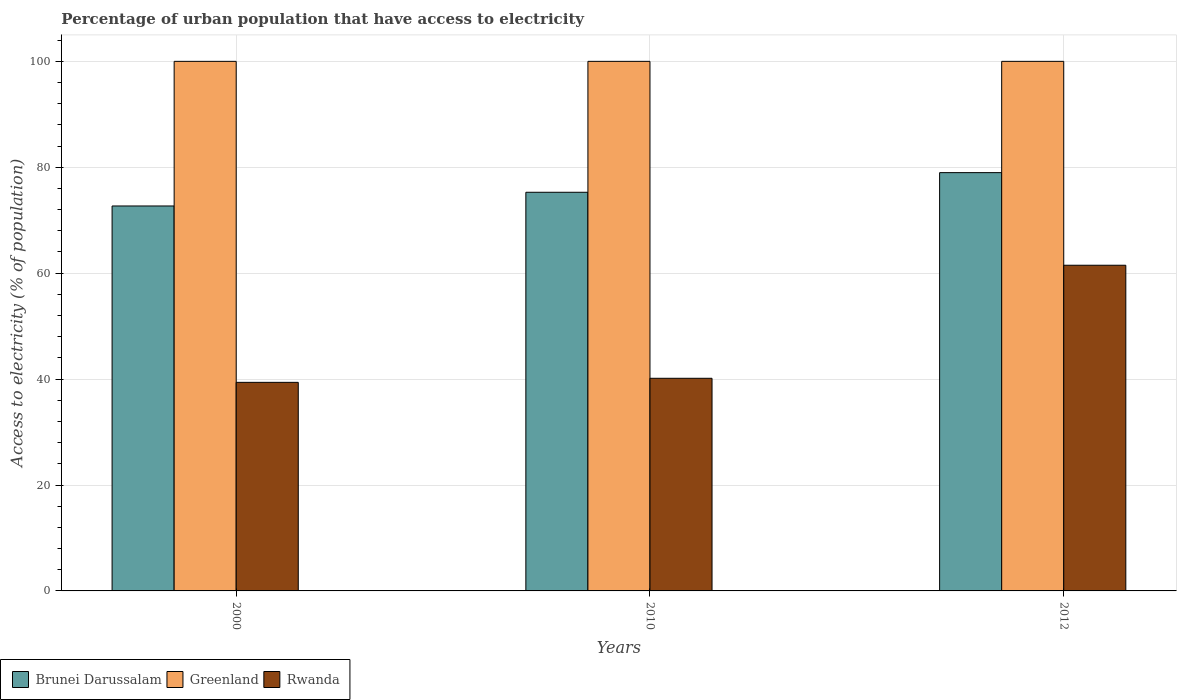How many groups of bars are there?
Ensure brevity in your answer.  3. Are the number of bars per tick equal to the number of legend labels?
Make the answer very short. Yes. Are the number of bars on each tick of the X-axis equal?
Keep it short and to the point. Yes. In how many cases, is the number of bars for a given year not equal to the number of legend labels?
Provide a succinct answer. 0. What is the percentage of urban population that have access to electricity in Brunei Darussalam in 2000?
Offer a very short reply. 72.69. Across all years, what is the maximum percentage of urban population that have access to electricity in Rwanda?
Keep it short and to the point. 61.5. Across all years, what is the minimum percentage of urban population that have access to electricity in Greenland?
Provide a short and direct response. 100. In which year was the percentage of urban population that have access to electricity in Rwanda minimum?
Provide a short and direct response. 2000. What is the total percentage of urban population that have access to electricity in Brunei Darussalam in the graph?
Your response must be concise. 226.96. What is the difference between the percentage of urban population that have access to electricity in Rwanda in 2010 and that in 2012?
Provide a succinct answer. -21.35. What is the difference between the percentage of urban population that have access to electricity in Brunei Darussalam in 2000 and the percentage of urban population that have access to electricity in Rwanda in 2012?
Provide a short and direct response. 11.19. What is the average percentage of urban population that have access to electricity in Greenland per year?
Make the answer very short. 100. In the year 2012, what is the difference between the percentage of urban population that have access to electricity in Rwanda and percentage of urban population that have access to electricity in Greenland?
Your response must be concise. -38.5. In how many years, is the percentage of urban population that have access to electricity in Brunei Darussalam greater than 4 %?
Offer a terse response. 3. What is the ratio of the percentage of urban population that have access to electricity in Brunei Darussalam in 2000 to that in 2010?
Keep it short and to the point. 0.97. Is the percentage of urban population that have access to electricity in Greenland in 2000 less than that in 2012?
Offer a terse response. No. What is the difference between the highest and the second highest percentage of urban population that have access to electricity in Brunei Darussalam?
Ensure brevity in your answer.  3.71. What is the difference between the highest and the lowest percentage of urban population that have access to electricity in Brunei Darussalam?
Your answer should be compact. 6.3. What does the 1st bar from the left in 2012 represents?
Your answer should be compact. Brunei Darussalam. What does the 2nd bar from the right in 2000 represents?
Provide a short and direct response. Greenland. Are all the bars in the graph horizontal?
Provide a succinct answer. No. How many years are there in the graph?
Provide a succinct answer. 3. What is the difference between two consecutive major ticks on the Y-axis?
Your response must be concise. 20. Are the values on the major ticks of Y-axis written in scientific E-notation?
Make the answer very short. No. Does the graph contain any zero values?
Provide a short and direct response. No. Where does the legend appear in the graph?
Provide a short and direct response. Bottom left. How many legend labels are there?
Ensure brevity in your answer.  3. What is the title of the graph?
Give a very brief answer. Percentage of urban population that have access to electricity. What is the label or title of the X-axis?
Give a very brief answer. Years. What is the label or title of the Y-axis?
Ensure brevity in your answer.  Access to electricity (% of population). What is the Access to electricity (% of population) of Brunei Darussalam in 2000?
Offer a terse response. 72.69. What is the Access to electricity (% of population) of Greenland in 2000?
Offer a terse response. 100. What is the Access to electricity (% of population) in Rwanda in 2000?
Provide a short and direct response. 39.38. What is the Access to electricity (% of population) in Brunei Darussalam in 2010?
Provide a succinct answer. 75.28. What is the Access to electricity (% of population) in Greenland in 2010?
Your answer should be compact. 100. What is the Access to electricity (% of population) in Rwanda in 2010?
Keep it short and to the point. 40.15. What is the Access to electricity (% of population) in Brunei Darussalam in 2012?
Offer a very short reply. 78.99. What is the Access to electricity (% of population) in Greenland in 2012?
Your answer should be very brief. 100. What is the Access to electricity (% of population) of Rwanda in 2012?
Offer a very short reply. 61.5. Across all years, what is the maximum Access to electricity (% of population) in Brunei Darussalam?
Offer a terse response. 78.99. Across all years, what is the maximum Access to electricity (% of population) of Greenland?
Make the answer very short. 100. Across all years, what is the maximum Access to electricity (% of population) of Rwanda?
Provide a short and direct response. 61.5. Across all years, what is the minimum Access to electricity (% of population) of Brunei Darussalam?
Keep it short and to the point. 72.69. Across all years, what is the minimum Access to electricity (% of population) in Rwanda?
Offer a very short reply. 39.38. What is the total Access to electricity (% of population) of Brunei Darussalam in the graph?
Your answer should be very brief. 226.96. What is the total Access to electricity (% of population) of Greenland in the graph?
Provide a succinct answer. 300. What is the total Access to electricity (% of population) of Rwanda in the graph?
Ensure brevity in your answer.  141.03. What is the difference between the Access to electricity (% of population) in Brunei Darussalam in 2000 and that in 2010?
Provide a succinct answer. -2.59. What is the difference between the Access to electricity (% of population) in Rwanda in 2000 and that in 2010?
Provide a short and direct response. -0.77. What is the difference between the Access to electricity (% of population) in Brunei Darussalam in 2000 and that in 2012?
Your response must be concise. -6.3. What is the difference between the Access to electricity (% of population) in Greenland in 2000 and that in 2012?
Offer a terse response. 0. What is the difference between the Access to electricity (% of population) of Rwanda in 2000 and that in 2012?
Ensure brevity in your answer.  -22.12. What is the difference between the Access to electricity (% of population) in Brunei Darussalam in 2010 and that in 2012?
Make the answer very short. -3.71. What is the difference between the Access to electricity (% of population) in Greenland in 2010 and that in 2012?
Provide a short and direct response. 0. What is the difference between the Access to electricity (% of population) in Rwanda in 2010 and that in 2012?
Offer a very short reply. -21.35. What is the difference between the Access to electricity (% of population) in Brunei Darussalam in 2000 and the Access to electricity (% of population) in Greenland in 2010?
Provide a succinct answer. -27.31. What is the difference between the Access to electricity (% of population) of Brunei Darussalam in 2000 and the Access to electricity (% of population) of Rwanda in 2010?
Give a very brief answer. 32.54. What is the difference between the Access to electricity (% of population) in Greenland in 2000 and the Access to electricity (% of population) in Rwanda in 2010?
Provide a succinct answer. 59.85. What is the difference between the Access to electricity (% of population) of Brunei Darussalam in 2000 and the Access to electricity (% of population) of Greenland in 2012?
Provide a succinct answer. -27.31. What is the difference between the Access to electricity (% of population) of Brunei Darussalam in 2000 and the Access to electricity (% of population) of Rwanda in 2012?
Offer a terse response. 11.19. What is the difference between the Access to electricity (% of population) of Greenland in 2000 and the Access to electricity (% of population) of Rwanda in 2012?
Your response must be concise. 38.5. What is the difference between the Access to electricity (% of population) of Brunei Darussalam in 2010 and the Access to electricity (% of population) of Greenland in 2012?
Your answer should be very brief. -24.72. What is the difference between the Access to electricity (% of population) of Brunei Darussalam in 2010 and the Access to electricity (% of population) of Rwanda in 2012?
Keep it short and to the point. 13.78. What is the difference between the Access to electricity (% of population) of Greenland in 2010 and the Access to electricity (% of population) of Rwanda in 2012?
Make the answer very short. 38.5. What is the average Access to electricity (% of population) in Brunei Darussalam per year?
Give a very brief answer. 75.65. What is the average Access to electricity (% of population) in Greenland per year?
Keep it short and to the point. 100. What is the average Access to electricity (% of population) of Rwanda per year?
Your answer should be very brief. 47.01. In the year 2000, what is the difference between the Access to electricity (% of population) in Brunei Darussalam and Access to electricity (% of population) in Greenland?
Your answer should be compact. -27.31. In the year 2000, what is the difference between the Access to electricity (% of population) in Brunei Darussalam and Access to electricity (% of population) in Rwanda?
Offer a very short reply. 33.31. In the year 2000, what is the difference between the Access to electricity (% of population) of Greenland and Access to electricity (% of population) of Rwanda?
Make the answer very short. 60.62. In the year 2010, what is the difference between the Access to electricity (% of population) of Brunei Darussalam and Access to electricity (% of population) of Greenland?
Offer a terse response. -24.72. In the year 2010, what is the difference between the Access to electricity (% of population) of Brunei Darussalam and Access to electricity (% of population) of Rwanda?
Make the answer very short. 35.13. In the year 2010, what is the difference between the Access to electricity (% of population) in Greenland and Access to electricity (% of population) in Rwanda?
Your answer should be compact. 59.85. In the year 2012, what is the difference between the Access to electricity (% of population) in Brunei Darussalam and Access to electricity (% of population) in Greenland?
Your answer should be compact. -21.01. In the year 2012, what is the difference between the Access to electricity (% of population) of Brunei Darussalam and Access to electricity (% of population) of Rwanda?
Keep it short and to the point. 17.49. In the year 2012, what is the difference between the Access to electricity (% of population) in Greenland and Access to electricity (% of population) in Rwanda?
Keep it short and to the point. 38.5. What is the ratio of the Access to electricity (% of population) in Brunei Darussalam in 2000 to that in 2010?
Offer a very short reply. 0.97. What is the ratio of the Access to electricity (% of population) in Rwanda in 2000 to that in 2010?
Offer a terse response. 0.98. What is the ratio of the Access to electricity (% of population) of Brunei Darussalam in 2000 to that in 2012?
Offer a terse response. 0.92. What is the ratio of the Access to electricity (% of population) in Greenland in 2000 to that in 2012?
Ensure brevity in your answer.  1. What is the ratio of the Access to electricity (% of population) in Rwanda in 2000 to that in 2012?
Give a very brief answer. 0.64. What is the ratio of the Access to electricity (% of population) in Brunei Darussalam in 2010 to that in 2012?
Provide a succinct answer. 0.95. What is the ratio of the Access to electricity (% of population) in Greenland in 2010 to that in 2012?
Offer a terse response. 1. What is the ratio of the Access to electricity (% of population) in Rwanda in 2010 to that in 2012?
Provide a succinct answer. 0.65. What is the difference between the highest and the second highest Access to electricity (% of population) of Brunei Darussalam?
Provide a succinct answer. 3.71. What is the difference between the highest and the second highest Access to electricity (% of population) of Greenland?
Provide a succinct answer. 0. What is the difference between the highest and the second highest Access to electricity (% of population) of Rwanda?
Ensure brevity in your answer.  21.35. What is the difference between the highest and the lowest Access to electricity (% of population) of Brunei Darussalam?
Keep it short and to the point. 6.3. What is the difference between the highest and the lowest Access to electricity (% of population) of Rwanda?
Your answer should be compact. 22.12. 